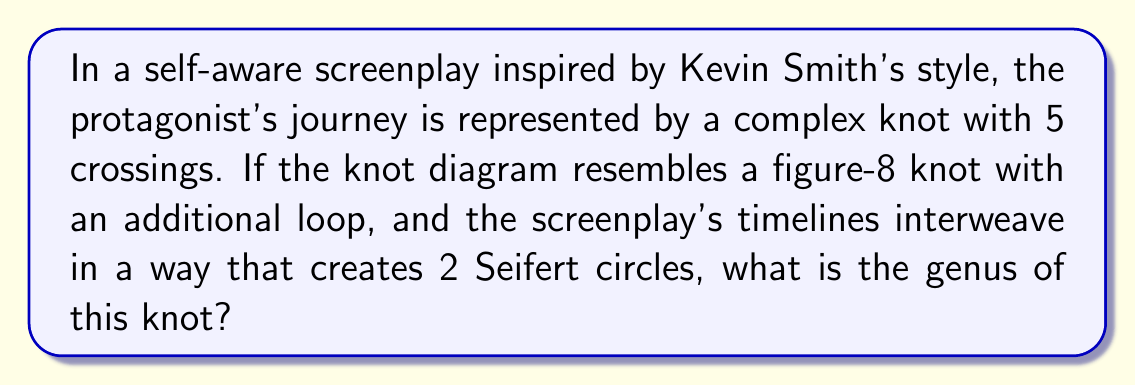Can you solve this math problem? To determine the genus of the knot, we'll follow these steps:

1. Identify the key components:
   - Number of crossings: $c = 5$
   - Number of Seifert circles: $s = 2$

2. Use the formula for the genus of a knot:
   $$g = \frac{1}{2}(c - s + 1)$$

   Where:
   $g$ is the genus
   $c$ is the number of crossings
   $s$ is the number of Seifert circles

3. Substitute the values into the formula:
   $$g = \frac{1}{2}(5 - 2 + 1)$$

4. Simplify:
   $$g = \frac{1}{2}(4)$$

5. Calculate the final result:
   $$g = 2$$

The genus of the knot representing the interwoven timelines in this self-referential screenplay is 2, reflecting the complexity of the non-linear narrative structure.
Answer: 2 